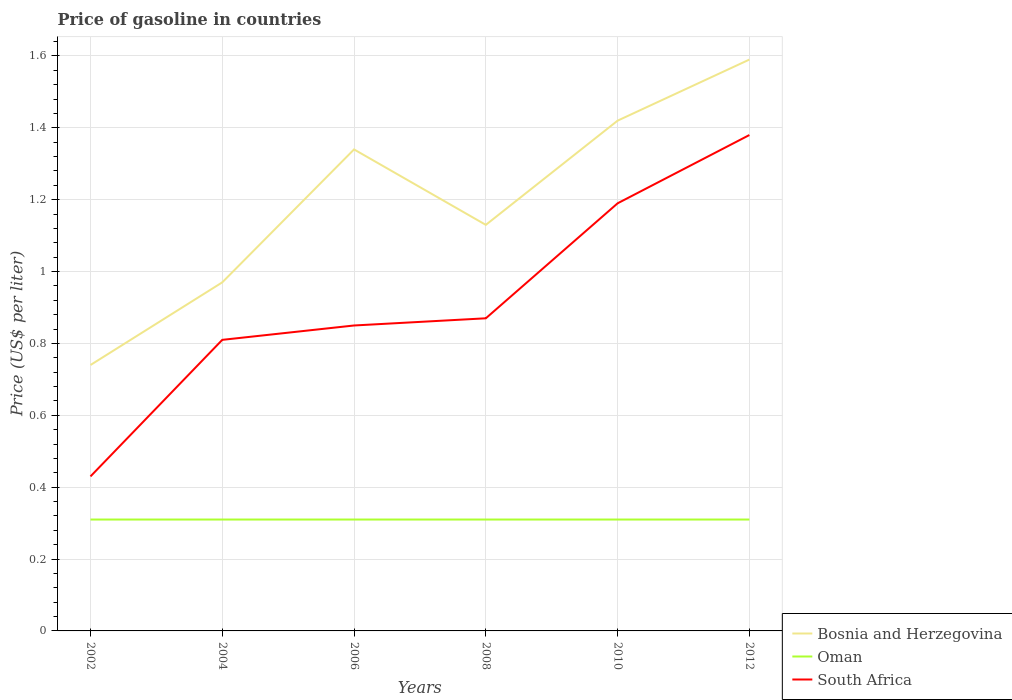How many different coloured lines are there?
Make the answer very short. 3. Is the number of lines equal to the number of legend labels?
Keep it short and to the point. Yes. Across all years, what is the maximum price of gasoline in Oman?
Give a very brief answer. 0.31. What is the total price of gasoline in Bosnia and Herzegovina in the graph?
Give a very brief answer. -0.17. What is the difference between the highest and the lowest price of gasoline in Oman?
Your answer should be very brief. 0. Is the price of gasoline in Oman strictly greater than the price of gasoline in Bosnia and Herzegovina over the years?
Give a very brief answer. Yes. What is the difference between two consecutive major ticks on the Y-axis?
Your answer should be compact. 0.2. How are the legend labels stacked?
Ensure brevity in your answer.  Vertical. What is the title of the graph?
Your answer should be very brief. Price of gasoline in countries. Does "Nepal" appear as one of the legend labels in the graph?
Your answer should be very brief. No. What is the label or title of the Y-axis?
Ensure brevity in your answer.  Price (US$ per liter). What is the Price (US$ per liter) in Bosnia and Herzegovina in 2002?
Your answer should be compact. 0.74. What is the Price (US$ per liter) in Oman in 2002?
Provide a short and direct response. 0.31. What is the Price (US$ per liter) in South Africa in 2002?
Your response must be concise. 0.43. What is the Price (US$ per liter) in Bosnia and Herzegovina in 2004?
Keep it short and to the point. 0.97. What is the Price (US$ per liter) in Oman in 2004?
Your answer should be compact. 0.31. What is the Price (US$ per liter) in South Africa in 2004?
Your answer should be compact. 0.81. What is the Price (US$ per liter) in Bosnia and Herzegovina in 2006?
Offer a terse response. 1.34. What is the Price (US$ per liter) in Oman in 2006?
Your answer should be very brief. 0.31. What is the Price (US$ per liter) of Bosnia and Herzegovina in 2008?
Offer a very short reply. 1.13. What is the Price (US$ per liter) of Oman in 2008?
Provide a succinct answer. 0.31. What is the Price (US$ per liter) of South Africa in 2008?
Offer a terse response. 0.87. What is the Price (US$ per liter) in Bosnia and Herzegovina in 2010?
Offer a terse response. 1.42. What is the Price (US$ per liter) in Oman in 2010?
Your response must be concise. 0.31. What is the Price (US$ per liter) of South Africa in 2010?
Give a very brief answer. 1.19. What is the Price (US$ per liter) of Bosnia and Herzegovina in 2012?
Offer a very short reply. 1.59. What is the Price (US$ per liter) in Oman in 2012?
Make the answer very short. 0.31. What is the Price (US$ per liter) of South Africa in 2012?
Provide a short and direct response. 1.38. Across all years, what is the maximum Price (US$ per liter) in Bosnia and Herzegovina?
Ensure brevity in your answer.  1.59. Across all years, what is the maximum Price (US$ per liter) of Oman?
Your answer should be compact. 0.31. Across all years, what is the maximum Price (US$ per liter) in South Africa?
Give a very brief answer. 1.38. Across all years, what is the minimum Price (US$ per liter) of Bosnia and Herzegovina?
Your response must be concise. 0.74. Across all years, what is the minimum Price (US$ per liter) of Oman?
Your response must be concise. 0.31. Across all years, what is the minimum Price (US$ per liter) in South Africa?
Ensure brevity in your answer.  0.43. What is the total Price (US$ per liter) in Bosnia and Herzegovina in the graph?
Your answer should be compact. 7.19. What is the total Price (US$ per liter) in Oman in the graph?
Make the answer very short. 1.86. What is the total Price (US$ per liter) of South Africa in the graph?
Give a very brief answer. 5.53. What is the difference between the Price (US$ per liter) in Bosnia and Herzegovina in 2002 and that in 2004?
Your answer should be very brief. -0.23. What is the difference between the Price (US$ per liter) in South Africa in 2002 and that in 2004?
Make the answer very short. -0.38. What is the difference between the Price (US$ per liter) in Bosnia and Herzegovina in 2002 and that in 2006?
Keep it short and to the point. -0.6. What is the difference between the Price (US$ per liter) in South Africa in 2002 and that in 2006?
Make the answer very short. -0.42. What is the difference between the Price (US$ per liter) of Bosnia and Herzegovina in 2002 and that in 2008?
Offer a very short reply. -0.39. What is the difference between the Price (US$ per liter) of Oman in 2002 and that in 2008?
Provide a short and direct response. 0. What is the difference between the Price (US$ per liter) of South Africa in 2002 and that in 2008?
Offer a terse response. -0.44. What is the difference between the Price (US$ per liter) in Bosnia and Herzegovina in 2002 and that in 2010?
Give a very brief answer. -0.68. What is the difference between the Price (US$ per liter) in South Africa in 2002 and that in 2010?
Provide a short and direct response. -0.76. What is the difference between the Price (US$ per liter) in Bosnia and Herzegovina in 2002 and that in 2012?
Give a very brief answer. -0.85. What is the difference between the Price (US$ per liter) in Oman in 2002 and that in 2012?
Your answer should be compact. 0. What is the difference between the Price (US$ per liter) of South Africa in 2002 and that in 2012?
Give a very brief answer. -0.95. What is the difference between the Price (US$ per liter) of Bosnia and Herzegovina in 2004 and that in 2006?
Keep it short and to the point. -0.37. What is the difference between the Price (US$ per liter) in South Africa in 2004 and that in 2006?
Give a very brief answer. -0.04. What is the difference between the Price (US$ per liter) in Bosnia and Herzegovina in 2004 and that in 2008?
Your answer should be compact. -0.16. What is the difference between the Price (US$ per liter) of Oman in 2004 and that in 2008?
Provide a short and direct response. 0. What is the difference between the Price (US$ per liter) in South Africa in 2004 and that in 2008?
Your answer should be very brief. -0.06. What is the difference between the Price (US$ per liter) of Bosnia and Herzegovina in 2004 and that in 2010?
Your answer should be very brief. -0.45. What is the difference between the Price (US$ per liter) in Oman in 2004 and that in 2010?
Your answer should be very brief. 0. What is the difference between the Price (US$ per liter) of South Africa in 2004 and that in 2010?
Offer a very short reply. -0.38. What is the difference between the Price (US$ per liter) in Bosnia and Herzegovina in 2004 and that in 2012?
Your answer should be compact. -0.62. What is the difference between the Price (US$ per liter) in South Africa in 2004 and that in 2012?
Make the answer very short. -0.57. What is the difference between the Price (US$ per liter) of Bosnia and Herzegovina in 2006 and that in 2008?
Make the answer very short. 0.21. What is the difference between the Price (US$ per liter) in Oman in 2006 and that in 2008?
Offer a terse response. 0. What is the difference between the Price (US$ per liter) in South Africa in 2006 and that in 2008?
Make the answer very short. -0.02. What is the difference between the Price (US$ per liter) of Bosnia and Herzegovina in 2006 and that in 2010?
Your response must be concise. -0.08. What is the difference between the Price (US$ per liter) of Oman in 2006 and that in 2010?
Make the answer very short. 0. What is the difference between the Price (US$ per liter) in South Africa in 2006 and that in 2010?
Your response must be concise. -0.34. What is the difference between the Price (US$ per liter) in South Africa in 2006 and that in 2012?
Offer a terse response. -0.53. What is the difference between the Price (US$ per liter) in Bosnia and Herzegovina in 2008 and that in 2010?
Make the answer very short. -0.29. What is the difference between the Price (US$ per liter) of South Africa in 2008 and that in 2010?
Your answer should be very brief. -0.32. What is the difference between the Price (US$ per liter) of Bosnia and Herzegovina in 2008 and that in 2012?
Offer a terse response. -0.46. What is the difference between the Price (US$ per liter) in South Africa in 2008 and that in 2012?
Give a very brief answer. -0.51. What is the difference between the Price (US$ per liter) of Bosnia and Herzegovina in 2010 and that in 2012?
Provide a short and direct response. -0.17. What is the difference between the Price (US$ per liter) in South Africa in 2010 and that in 2012?
Offer a terse response. -0.19. What is the difference between the Price (US$ per liter) in Bosnia and Herzegovina in 2002 and the Price (US$ per liter) in Oman in 2004?
Ensure brevity in your answer.  0.43. What is the difference between the Price (US$ per liter) of Bosnia and Herzegovina in 2002 and the Price (US$ per liter) of South Africa in 2004?
Keep it short and to the point. -0.07. What is the difference between the Price (US$ per liter) of Oman in 2002 and the Price (US$ per liter) of South Africa in 2004?
Keep it short and to the point. -0.5. What is the difference between the Price (US$ per liter) in Bosnia and Herzegovina in 2002 and the Price (US$ per liter) in Oman in 2006?
Offer a very short reply. 0.43. What is the difference between the Price (US$ per liter) in Bosnia and Herzegovina in 2002 and the Price (US$ per liter) in South Africa in 2006?
Provide a short and direct response. -0.11. What is the difference between the Price (US$ per liter) in Oman in 2002 and the Price (US$ per liter) in South Africa in 2006?
Ensure brevity in your answer.  -0.54. What is the difference between the Price (US$ per liter) in Bosnia and Herzegovina in 2002 and the Price (US$ per liter) in Oman in 2008?
Keep it short and to the point. 0.43. What is the difference between the Price (US$ per liter) of Bosnia and Herzegovina in 2002 and the Price (US$ per liter) of South Africa in 2008?
Keep it short and to the point. -0.13. What is the difference between the Price (US$ per liter) of Oman in 2002 and the Price (US$ per liter) of South Africa in 2008?
Ensure brevity in your answer.  -0.56. What is the difference between the Price (US$ per liter) in Bosnia and Herzegovina in 2002 and the Price (US$ per liter) in Oman in 2010?
Your answer should be very brief. 0.43. What is the difference between the Price (US$ per liter) in Bosnia and Herzegovina in 2002 and the Price (US$ per liter) in South Africa in 2010?
Keep it short and to the point. -0.45. What is the difference between the Price (US$ per liter) in Oman in 2002 and the Price (US$ per liter) in South Africa in 2010?
Provide a succinct answer. -0.88. What is the difference between the Price (US$ per liter) in Bosnia and Herzegovina in 2002 and the Price (US$ per liter) in Oman in 2012?
Offer a very short reply. 0.43. What is the difference between the Price (US$ per liter) in Bosnia and Herzegovina in 2002 and the Price (US$ per liter) in South Africa in 2012?
Provide a succinct answer. -0.64. What is the difference between the Price (US$ per liter) in Oman in 2002 and the Price (US$ per liter) in South Africa in 2012?
Give a very brief answer. -1.07. What is the difference between the Price (US$ per liter) of Bosnia and Herzegovina in 2004 and the Price (US$ per liter) of Oman in 2006?
Your response must be concise. 0.66. What is the difference between the Price (US$ per liter) of Bosnia and Herzegovina in 2004 and the Price (US$ per liter) of South Africa in 2006?
Give a very brief answer. 0.12. What is the difference between the Price (US$ per liter) in Oman in 2004 and the Price (US$ per liter) in South Africa in 2006?
Provide a succinct answer. -0.54. What is the difference between the Price (US$ per liter) of Bosnia and Herzegovina in 2004 and the Price (US$ per liter) of Oman in 2008?
Ensure brevity in your answer.  0.66. What is the difference between the Price (US$ per liter) in Bosnia and Herzegovina in 2004 and the Price (US$ per liter) in South Africa in 2008?
Make the answer very short. 0.1. What is the difference between the Price (US$ per liter) in Oman in 2004 and the Price (US$ per liter) in South Africa in 2008?
Offer a terse response. -0.56. What is the difference between the Price (US$ per liter) of Bosnia and Herzegovina in 2004 and the Price (US$ per liter) of Oman in 2010?
Offer a terse response. 0.66. What is the difference between the Price (US$ per liter) of Bosnia and Herzegovina in 2004 and the Price (US$ per liter) of South Africa in 2010?
Your answer should be compact. -0.22. What is the difference between the Price (US$ per liter) in Oman in 2004 and the Price (US$ per liter) in South Africa in 2010?
Give a very brief answer. -0.88. What is the difference between the Price (US$ per liter) of Bosnia and Herzegovina in 2004 and the Price (US$ per liter) of Oman in 2012?
Provide a succinct answer. 0.66. What is the difference between the Price (US$ per liter) of Bosnia and Herzegovina in 2004 and the Price (US$ per liter) of South Africa in 2012?
Your answer should be compact. -0.41. What is the difference between the Price (US$ per liter) in Oman in 2004 and the Price (US$ per liter) in South Africa in 2012?
Your response must be concise. -1.07. What is the difference between the Price (US$ per liter) in Bosnia and Herzegovina in 2006 and the Price (US$ per liter) in South Africa in 2008?
Keep it short and to the point. 0.47. What is the difference between the Price (US$ per liter) in Oman in 2006 and the Price (US$ per liter) in South Africa in 2008?
Your answer should be very brief. -0.56. What is the difference between the Price (US$ per liter) of Oman in 2006 and the Price (US$ per liter) of South Africa in 2010?
Your answer should be compact. -0.88. What is the difference between the Price (US$ per liter) of Bosnia and Herzegovina in 2006 and the Price (US$ per liter) of South Africa in 2012?
Offer a terse response. -0.04. What is the difference between the Price (US$ per liter) in Oman in 2006 and the Price (US$ per liter) in South Africa in 2012?
Your answer should be compact. -1.07. What is the difference between the Price (US$ per liter) of Bosnia and Herzegovina in 2008 and the Price (US$ per liter) of Oman in 2010?
Your answer should be very brief. 0.82. What is the difference between the Price (US$ per liter) in Bosnia and Herzegovina in 2008 and the Price (US$ per liter) in South Africa in 2010?
Ensure brevity in your answer.  -0.06. What is the difference between the Price (US$ per liter) in Oman in 2008 and the Price (US$ per liter) in South Africa in 2010?
Your answer should be compact. -0.88. What is the difference between the Price (US$ per liter) of Bosnia and Herzegovina in 2008 and the Price (US$ per liter) of Oman in 2012?
Your answer should be compact. 0.82. What is the difference between the Price (US$ per liter) of Bosnia and Herzegovina in 2008 and the Price (US$ per liter) of South Africa in 2012?
Make the answer very short. -0.25. What is the difference between the Price (US$ per liter) in Oman in 2008 and the Price (US$ per liter) in South Africa in 2012?
Offer a very short reply. -1.07. What is the difference between the Price (US$ per liter) in Bosnia and Herzegovina in 2010 and the Price (US$ per liter) in Oman in 2012?
Provide a succinct answer. 1.11. What is the difference between the Price (US$ per liter) in Oman in 2010 and the Price (US$ per liter) in South Africa in 2012?
Offer a very short reply. -1.07. What is the average Price (US$ per liter) of Bosnia and Herzegovina per year?
Keep it short and to the point. 1.2. What is the average Price (US$ per liter) in Oman per year?
Give a very brief answer. 0.31. What is the average Price (US$ per liter) in South Africa per year?
Your answer should be very brief. 0.92. In the year 2002, what is the difference between the Price (US$ per liter) in Bosnia and Herzegovina and Price (US$ per liter) in Oman?
Keep it short and to the point. 0.43. In the year 2002, what is the difference between the Price (US$ per liter) of Bosnia and Herzegovina and Price (US$ per liter) of South Africa?
Provide a short and direct response. 0.31. In the year 2002, what is the difference between the Price (US$ per liter) of Oman and Price (US$ per liter) of South Africa?
Give a very brief answer. -0.12. In the year 2004, what is the difference between the Price (US$ per liter) of Bosnia and Herzegovina and Price (US$ per liter) of Oman?
Offer a very short reply. 0.66. In the year 2004, what is the difference between the Price (US$ per liter) in Bosnia and Herzegovina and Price (US$ per liter) in South Africa?
Your response must be concise. 0.16. In the year 2006, what is the difference between the Price (US$ per liter) of Bosnia and Herzegovina and Price (US$ per liter) of Oman?
Keep it short and to the point. 1.03. In the year 2006, what is the difference between the Price (US$ per liter) in Bosnia and Herzegovina and Price (US$ per liter) in South Africa?
Offer a very short reply. 0.49. In the year 2006, what is the difference between the Price (US$ per liter) of Oman and Price (US$ per liter) of South Africa?
Give a very brief answer. -0.54. In the year 2008, what is the difference between the Price (US$ per liter) in Bosnia and Herzegovina and Price (US$ per liter) in Oman?
Make the answer very short. 0.82. In the year 2008, what is the difference between the Price (US$ per liter) of Bosnia and Herzegovina and Price (US$ per liter) of South Africa?
Offer a very short reply. 0.26. In the year 2008, what is the difference between the Price (US$ per liter) of Oman and Price (US$ per liter) of South Africa?
Make the answer very short. -0.56. In the year 2010, what is the difference between the Price (US$ per liter) in Bosnia and Herzegovina and Price (US$ per liter) in Oman?
Your answer should be very brief. 1.11. In the year 2010, what is the difference between the Price (US$ per liter) of Bosnia and Herzegovina and Price (US$ per liter) of South Africa?
Your response must be concise. 0.23. In the year 2010, what is the difference between the Price (US$ per liter) of Oman and Price (US$ per liter) of South Africa?
Provide a short and direct response. -0.88. In the year 2012, what is the difference between the Price (US$ per liter) in Bosnia and Herzegovina and Price (US$ per liter) in Oman?
Your answer should be compact. 1.28. In the year 2012, what is the difference between the Price (US$ per liter) in Bosnia and Herzegovina and Price (US$ per liter) in South Africa?
Provide a succinct answer. 0.21. In the year 2012, what is the difference between the Price (US$ per liter) of Oman and Price (US$ per liter) of South Africa?
Ensure brevity in your answer.  -1.07. What is the ratio of the Price (US$ per liter) in Bosnia and Herzegovina in 2002 to that in 2004?
Provide a succinct answer. 0.76. What is the ratio of the Price (US$ per liter) in South Africa in 2002 to that in 2004?
Offer a terse response. 0.53. What is the ratio of the Price (US$ per liter) of Bosnia and Herzegovina in 2002 to that in 2006?
Ensure brevity in your answer.  0.55. What is the ratio of the Price (US$ per liter) of Oman in 2002 to that in 2006?
Your answer should be very brief. 1. What is the ratio of the Price (US$ per liter) in South Africa in 2002 to that in 2006?
Make the answer very short. 0.51. What is the ratio of the Price (US$ per liter) in Bosnia and Herzegovina in 2002 to that in 2008?
Offer a terse response. 0.65. What is the ratio of the Price (US$ per liter) of South Africa in 2002 to that in 2008?
Make the answer very short. 0.49. What is the ratio of the Price (US$ per liter) of Bosnia and Herzegovina in 2002 to that in 2010?
Your answer should be very brief. 0.52. What is the ratio of the Price (US$ per liter) of South Africa in 2002 to that in 2010?
Give a very brief answer. 0.36. What is the ratio of the Price (US$ per liter) in Bosnia and Herzegovina in 2002 to that in 2012?
Your answer should be compact. 0.47. What is the ratio of the Price (US$ per liter) in South Africa in 2002 to that in 2012?
Give a very brief answer. 0.31. What is the ratio of the Price (US$ per liter) of Bosnia and Herzegovina in 2004 to that in 2006?
Provide a succinct answer. 0.72. What is the ratio of the Price (US$ per liter) of Oman in 2004 to that in 2006?
Keep it short and to the point. 1. What is the ratio of the Price (US$ per liter) in South Africa in 2004 to that in 2006?
Provide a succinct answer. 0.95. What is the ratio of the Price (US$ per liter) of Bosnia and Herzegovina in 2004 to that in 2008?
Your answer should be very brief. 0.86. What is the ratio of the Price (US$ per liter) of Bosnia and Herzegovina in 2004 to that in 2010?
Provide a succinct answer. 0.68. What is the ratio of the Price (US$ per liter) in Oman in 2004 to that in 2010?
Offer a very short reply. 1. What is the ratio of the Price (US$ per liter) in South Africa in 2004 to that in 2010?
Provide a short and direct response. 0.68. What is the ratio of the Price (US$ per liter) of Bosnia and Herzegovina in 2004 to that in 2012?
Give a very brief answer. 0.61. What is the ratio of the Price (US$ per liter) in South Africa in 2004 to that in 2012?
Keep it short and to the point. 0.59. What is the ratio of the Price (US$ per liter) in Bosnia and Herzegovina in 2006 to that in 2008?
Offer a very short reply. 1.19. What is the ratio of the Price (US$ per liter) in South Africa in 2006 to that in 2008?
Your answer should be very brief. 0.98. What is the ratio of the Price (US$ per liter) of Bosnia and Herzegovina in 2006 to that in 2010?
Give a very brief answer. 0.94. What is the ratio of the Price (US$ per liter) of Oman in 2006 to that in 2010?
Your answer should be very brief. 1. What is the ratio of the Price (US$ per liter) in South Africa in 2006 to that in 2010?
Make the answer very short. 0.71. What is the ratio of the Price (US$ per liter) of Bosnia and Herzegovina in 2006 to that in 2012?
Your answer should be compact. 0.84. What is the ratio of the Price (US$ per liter) in South Africa in 2006 to that in 2012?
Ensure brevity in your answer.  0.62. What is the ratio of the Price (US$ per liter) of Bosnia and Herzegovina in 2008 to that in 2010?
Provide a succinct answer. 0.8. What is the ratio of the Price (US$ per liter) in Oman in 2008 to that in 2010?
Keep it short and to the point. 1. What is the ratio of the Price (US$ per liter) of South Africa in 2008 to that in 2010?
Make the answer very short. 0.73. What is the ratio of the Price (US$ per liter) in Bosnia and Herzegovina in 2008 to that in 2012?
Offer a very short reply. 0.71. What is the ratio of the Price (US$ per liter) in South Africa in 2008 to that in 2012?
Your answer should be compact. 0.63. What is the ratio of the Price (US$ per liter) in Bosnia and Herzegovina in 2010 to that in 2012?
Provide a short and direct response. 0.89. What is the ratio of the Price (US$ per liter) in South Africa in 2010 to that in 2012?
Ensure brevity in your answer.  0.86. What is the difference between the highest and the second highest Price (US$ per liter) in Bosnia and Herzegovina?
Keep it short and to the point. 0.17. What is the difference between the highest and the second highest Price (US$ per liter) in Oman?
Keep it short and to the point. 0. What is the difference between the highest and the second highest Price (US$ per liter) in South Africa?
Provide a succinct answer. 0.19. What is the difference between the highest and the lowest Price (US$ per liter) in Bosnia and Herzegovina?
Offer a very short reply. 0.85. What is the difference between the highest and the lowest Price (US$ per liter) in Oman?
Provide a short and direct response. 0. What is the difference between the highest and the lowest Price (US$ per liter) of South Africa?
Make the answer very short. 0.95. 